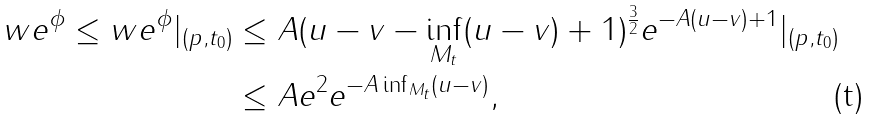<formula> <loc_0><loc_0><loc_500><loc_500>w e ^ { \phi } \leq w e ^ { \phi } | _ { ( p , t _ { 0 } ) } & \leq A ( u - v - \inf _ { M _ { t } } ( u - v ) + 1 ) ^ { \frac { 3 } { 2 } } e ^ { - A ( u - v ) + 1 } | _ { ( p , t _ { 0 } ) } \\ & \leq A e ^ { 2 } e ^ { - A \inf _ { M _ { t } } ( u - v ) } ,</formula> 